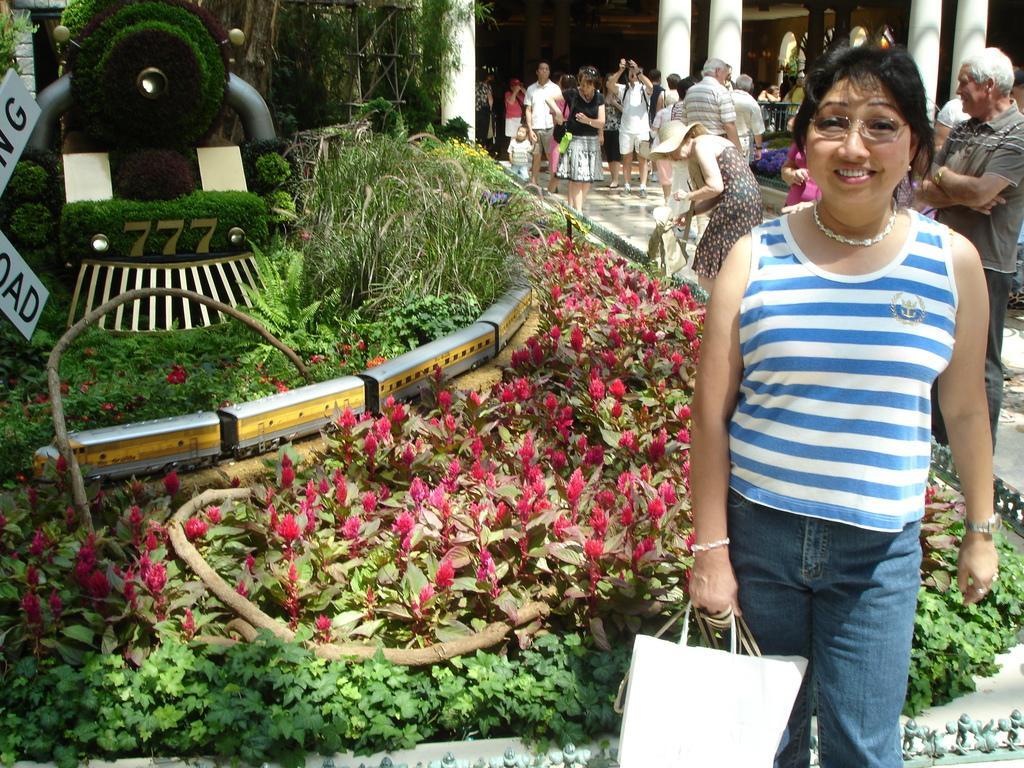Please provide a concise description of this image. In this image i can see there are group of people standing inside of the building and on the right side i can see a woman wearing a blue and white color shirt. t-shirt,she is smiling ,she is wearing a spectacles and her left hand she holding a carry bags and there are some bushes. on the bushes there is a train and there is a grass and there are some trees ,there are some flowers on the bushes. 